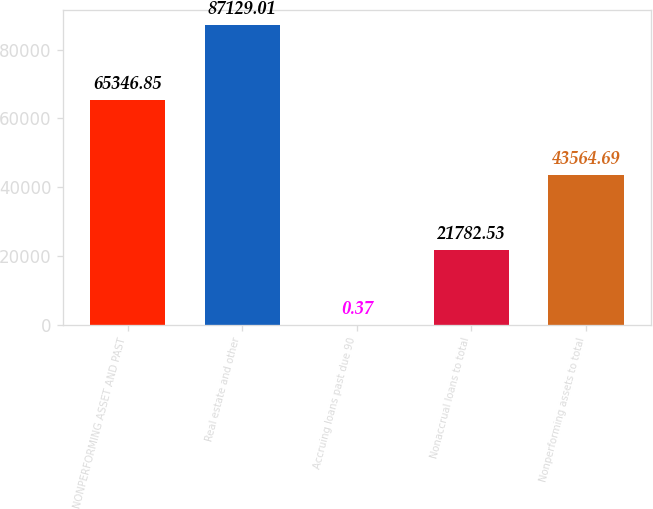Convert chart to OTSL. <chart><loc_0><loc_0><loc_500><loc_500><bar_chart><fcel>NONPERFORMING ASSET AND PAST<fcel>Real estate and other<fcel>Accruing loans past due 90<fcel>Nonaccrual loans to total<fcel>Nonperforming assets to total<nl><fcel>65346.8<fcel>87129<fcel>0.37<fcel>21782.5<fcel>43564.7<nl></chart> 